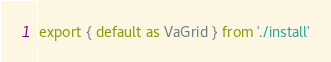<code> <loc_0><loc_0><loc_500><loc_500><_JavaScript_>export { default as VaGrid } from './install'
</code> 